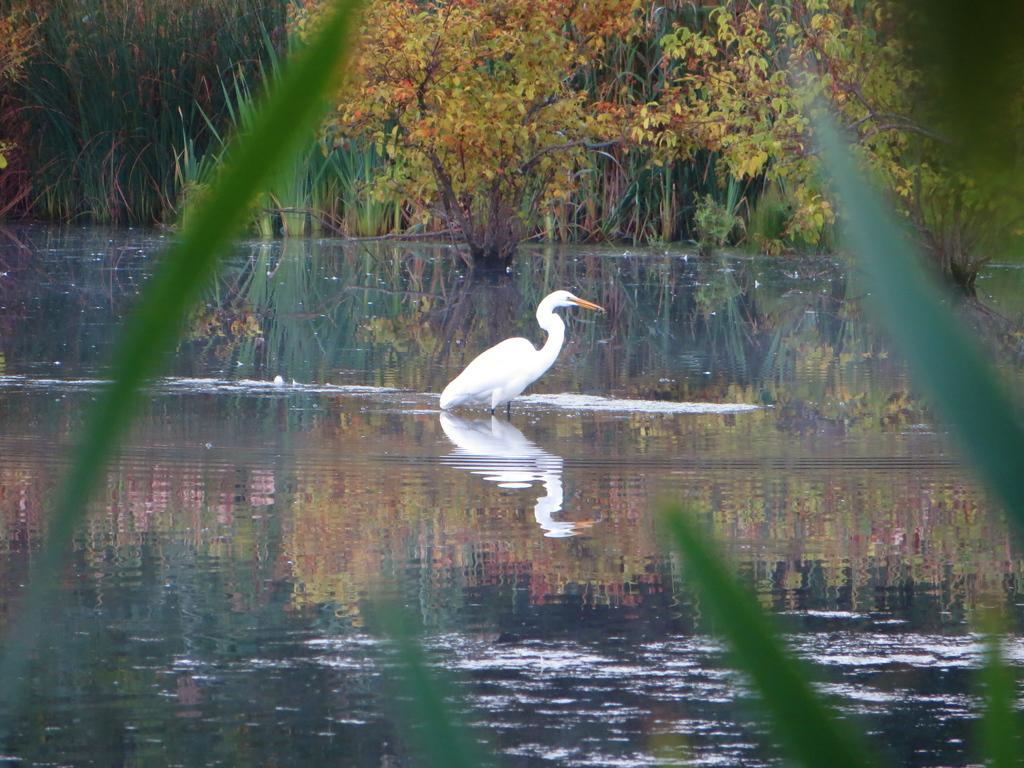What type of machinery can be seen in the image? There is a crane present in the image. What is the primary characteristic of the area in the image? The area is covered with water. What type of vegetation is visible in the image? There are plants and trees present in the image. What type of mint can be seen growing near the crane in the image? There is no mint visible in the image; it only features a crane, water, plants, and trees. What type of rod is being used by the crane operator in the image? There is no rod visible in the image, nor is there any indication of a crane operator. 